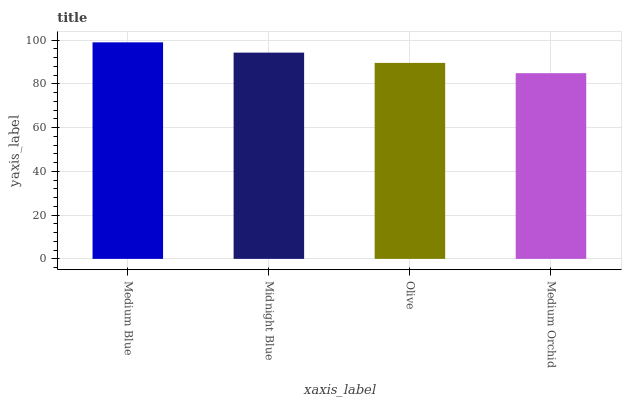Is Medium Orchid the minimum?
Answer yes or no. Yes. Is Medium Blue the maximum?
Answer yes or no. Yes. Is Midnight Blue the minimum?
Answer yes or no. No. Is Midnight Blue the maximum?
Answer yes or no. No. Is Medium Blue greater than Midnight Blue?
Answer yes or no. Yes. Is Midnight Blue less than Medium Blue?
Answer yes or no. Yes. Is Midnight Blue greater than Medium Blue?
Answer yes or no. No. Is Medium Blue less than Midnight Blue?
Answer yes or no. No. Is Midnight Blue the high median?
Answer yes or no. Yes. Is Olive the low median?
Answer yes or no. Yes. Is Medium Orchid the high median?
Answer yes or no. No. Is Midnight Blue the low median?
Answer yes or no. No. 